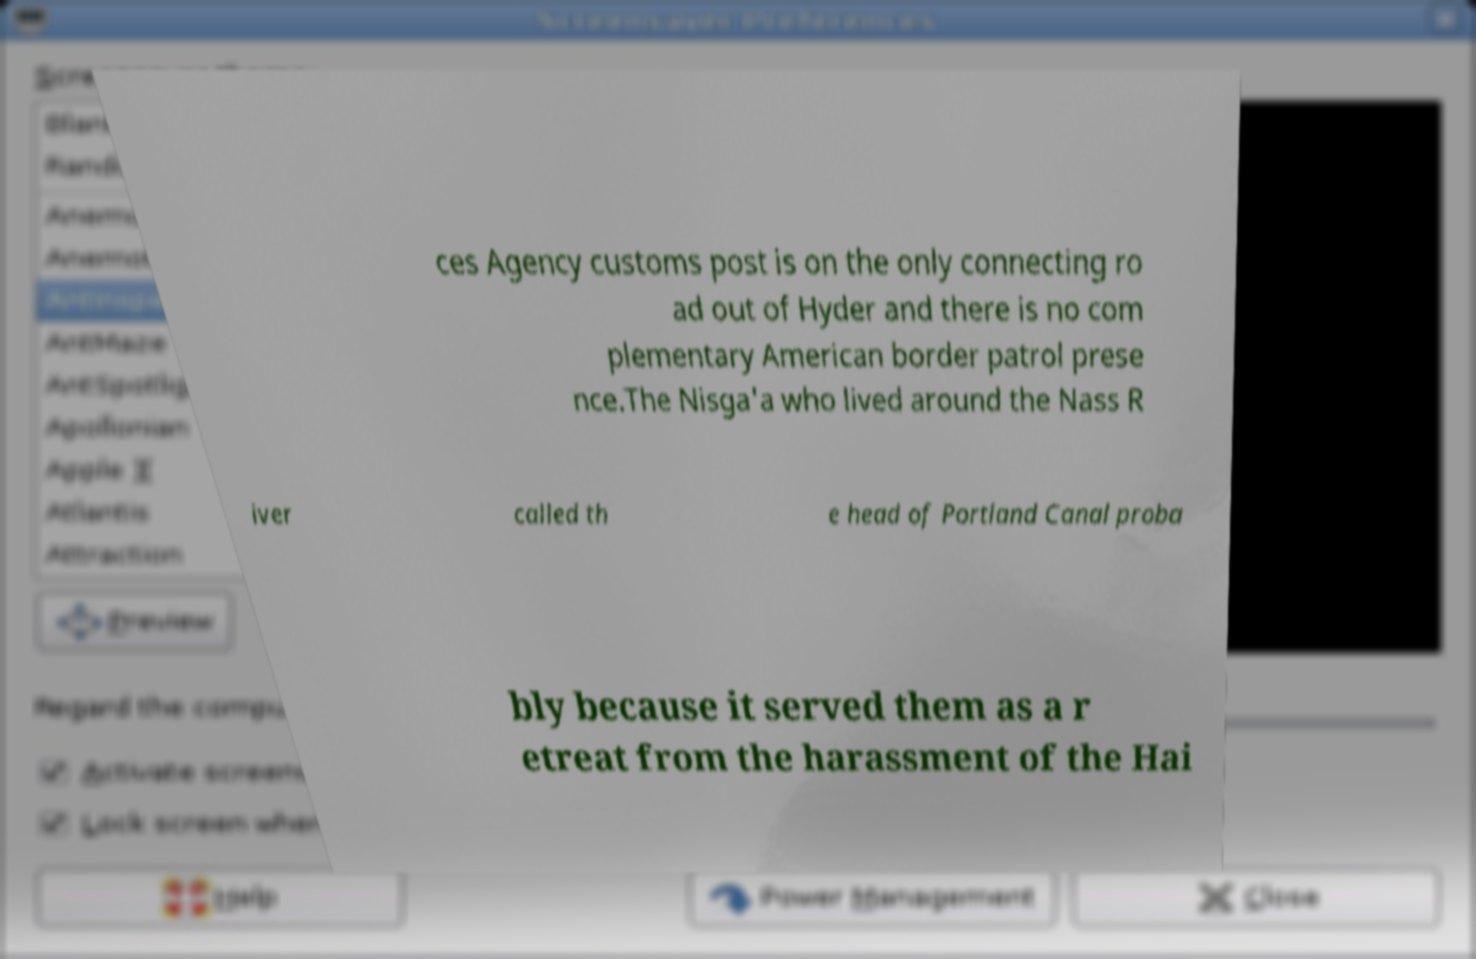Can you read and provide the text displayed in the image?This photo seems to have some interesting text. Can you extract and type it out for me? ces Agency customs post is on the only connecting ro ad out of Hyder and there is no com plementary American border patrol prese nce.The Nisga'a who lived around the Nass R iver called th e head of Portland Canal proba bly because it served them as a r etreat from the harassment of the Hai 